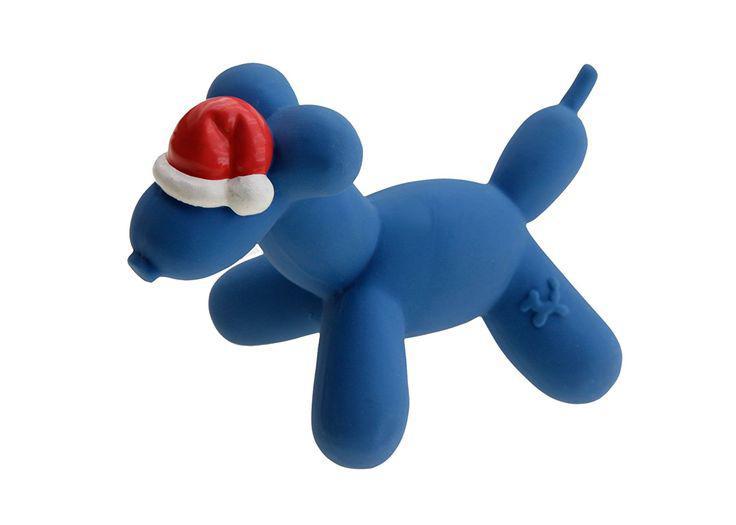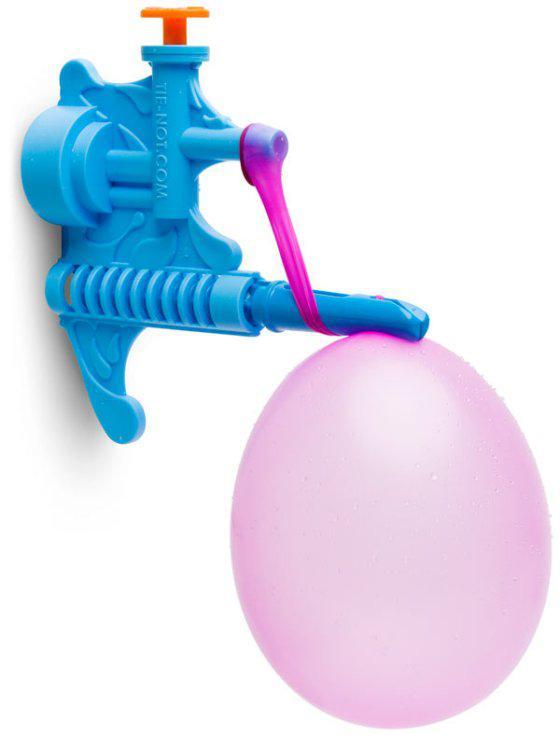The first image is the image on the left, the second image is the image on the right. Given the left and right images, does the statement "At least one balloon has a string attached." hold true? Answer yes or no. No. 